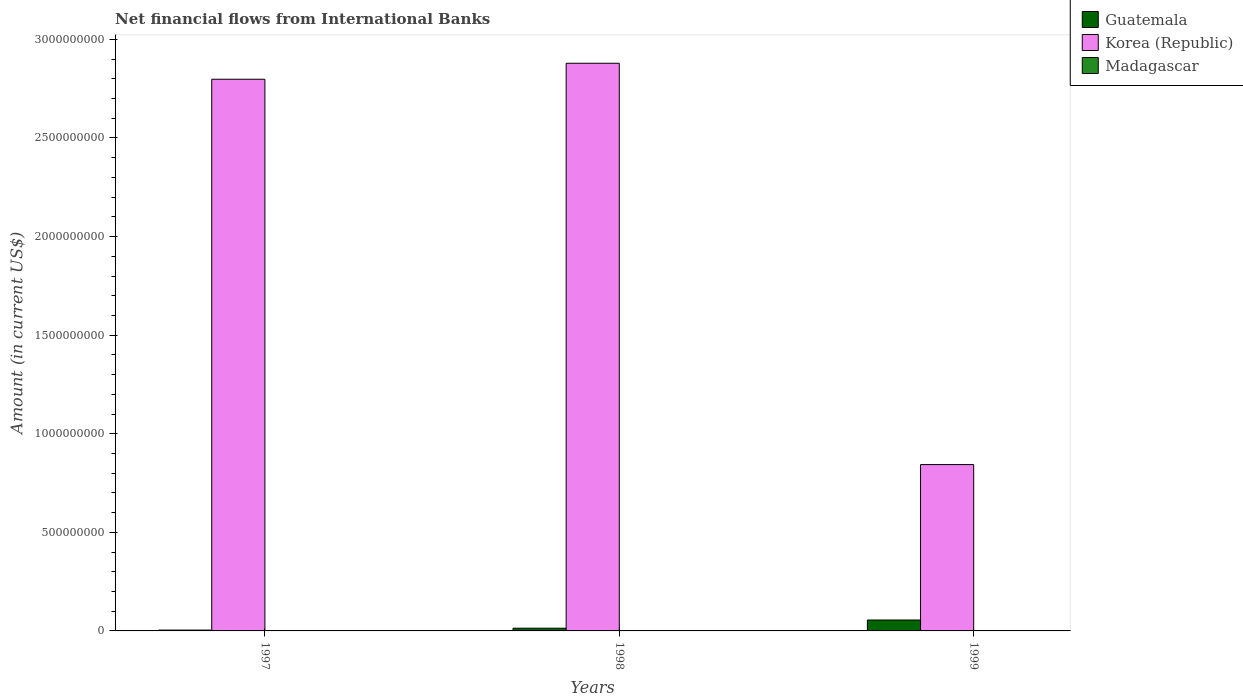How many different coloured bars are there?
Your response must be concise. 2. Are the number of bars per tick equal to the number of legend labels?
Keep it short and to the point. No. Are the number of bars on each tick of the X-axis equal?
Provide a succinct answer. Yes. How many bars are there on the 2nd tick from the left?
Keep it short and to the point. 2. How many bars are there on the 1st tick from the right?
Your response must be concise. 2. In how many cases, is the number of bars for a given year not equal to the number of legend labels?
Your answer should be very brief. 3. What is the net financial aid flows in Korea (Republic) in 1998?
Your answer should be very brief. 2.88e+09. Across all years, what is the maximum net financial aid flows in Guatemala?
Keep it short and to the point. 5.53e+07. Across all years, what is the minimum net financial aid flows in Korea (Republic)?
Offer a terse response. 8.44e+08. In which year was the net financial aid flows in Korea (Republic) maximum?
Ensure brevity in your answer.  1998. What is the total net financial aid flows in Korea (Republic) in the graph?
Ensure brevity in your answer.  6.52e+09. What is the difference between the net financial aid flows in Korea (Republic) in 1998 and that in 1999?
Offer a terse response. 2.04e+09. What is the difference between the net financial aid flows in Korea (Republic) in 1997 and the net financial aid flows in Madagascar in 1999?
Give a very brief answer. 2.80e+09. What is the average net financial aid flows in Korea (Republic) per year?
Provide a short and direct response. 2.17e+09. What is the ratio of the net financial aid flows in Guatemala in 1997 to that in 1999?
Give a very brief answer. 0.08. Is the net financial aid flows in Korea (Republic) in 1998 less than that in 1999?
Your answer should be compact. No. What is the difference between the highest and the second highest net financial aid flows in Korea (Republic)?
Make the answer very short. 8.11e+07. What is the difference between the highest and the lowest net financial aid flows in Guatemala?
Ensure brevity in your answer.  5.11e+07. Is the sum of the net financial aid flows in Guatemala in 1997 and 1999 greater than the maximum net financial aid flows in Madagascar across all years?
Your answer should be very brief. Yes. Is it the case that in every year, the sum of the net financial aid flows in Madagascar and net financial aid flows in Guatemala is greater than the net financial aid flows in Korea (Republic)?
Make the answer very short. No. How many bars are there?
Provide a succinct answer. 6. Are all the bars in the graph horizontal?
Your response must be concise. No. How many years are there in the graph?
Make the answer very short. 3. Are the values on the major ticks of Y-axis written in scientific E-notation?
Make the answer very short. No. Does the graph contain any zero values?
Make the answer very short. Yes. Does the graph contain grids?
Your answer should be compact. No. How many legend labels are there?
Offer a terse response. 3. How are the legend labels stacked?
Keep it short and to the point. Vertical. What is the title of the graph?
Keep it short and to the point. Net financial flows from International Banks. Does "Niger" appear as one of the legend labels in the graph?
Offer a terse response. No. What is the Amount (in current US$) in Guatemala in 1997?
Provide a short and direct response. 4.26e+06. What is the Amount (in current US$) of Korea (Republic) in 1997?
Provide a succinct answer. 2.80e+09. What is the Amount (in current US$) in Guatemala in 1998?
Offer a very short reply. 1.38e+07. What is the Amount (in current US$) of Korea (Republic) in 1998?
Offer a terse response. 2.88e+09. What is the Amount (in current US$) in Madagascar in 1998?
Provide a succinct answer. 0. What is the Amount (in current US$) of Guatemala in 1999?
Provide a succinct answer. 5.53e+07. What is the Amount (in current US$) in Korea (Republic) in 1999?
Offer a terse response. 8.44e+08. Across all years, what is the maximum Amount (in current US$) of Guatemala?
Offer a very short reply. 5.53e+07. Across all years, what is the maximum Amount (in current US$) in Korea (Republic)?
Your answer should be compact. 2.88e+09. Across all years, what is the minimum Amount (in current US$) of Guatemala?
Offer a terse response. 4.26e+06. Across all years, what is the minimum Amount (in current US$) of Korea (Republic)?
Offer a very short reply. 8.44e+08. What is the total Amount (in current US$) in Guatemala in the graph?
Make the answer very short. 7.34e+07. What is the total Amount (in current US$) of Korea (Republic) in the graph?
Offer a terse response. 6.52e+09. What is the difference between the Amount (in current US$) in Guatemala in 1997 and that in 1998?
Ensure brevity in your answer.  -9.52e+06. What is the difference between the Amount (in current US$) of Korea (Republic) in 1997 and that in 1998?
Make the answer very short. -8.11e+07. What is the difference between the Amount (in current US$) in Guatemala in 1997 and that in 1999?
Make the answer very short. -5.11e+07. What is the difference between the Amount (in current US$) of Korea (Republic) in 1997 and that in 1999?
Your answer should be very brief. 1.95e+09. What is the difference between the Amount (in current US$) of Guatemala in 1998 and that in 1999?
Keep it short and to the point. -4.15e+07. What is the difference between the Amount (in current US$) of Korea (Republic) in 1998 and that in 1999?
Provide a succinct answer. 2.04e+09. What is the difference between the Amount (in current US$) in Guatemala in 1997 and the Amount (in current US$) in Korea (Republic) in 1998?
Your response must be concise. -2.87e+09. What is the difference between the Amount (in current US$) in Guatemala in 1997 and the Amount (in current US$) in Korea (Republic) in 1999?
Give a very brief answer. -8.39e+08. What is the difference between the Amount (in current US$) of Guatemala in 1998 and the Amount (in current US$) of Korea (Republic) in 1999?
Offer a very short reply. -8.30e+08. What is the average Amount (in current US$) in Guatemala per year?
Offer a very short reply. 2.45e+07. What is the average Amount (in current US$) in Korea (Republic) per year?
Provide a short and direct response. 2.17e+09. What is the average Amount (in current US$) of Madagascar per year?
Provide a short and direct response. 0. In the year 1997, what is the difference between the Amount (in current US$) of Guatemala and Amount (in current US$) of Korea (Republic)?
Make the answer very short. -2.79e+09. In the year 1998, what is the difference between the Amount (in current US$) in Guatemala and Amount (in current US$) in Korea (Republic)?
Your response must be concise. -2.87e+09. In the year 1999, what is the difference between the Amount (in current US$) of Guatemala and Amount (in current US$) of Korea (Republic)?
Keep it short and to the point. -7.88e+08. What is the ratio of the Amount (in current US$) in Guatemala in 1997 to that in 1998?
Offer a terse response. 0.31. What is the ratio of the Amount (in current US$) of Korea (Republic) in 1997 to that in 1998?
Your response must be concise. 0.97. What is the ratio of the Amount (in current US$) of Guatemala in 1997 to that in 1999?
Offer a very short reply. 0.08. What is the ratio of the Amount (in current US$) in Korea (Republic) in 1997 to that in 1999?
Give a very brief answer. 3.32. What is the ratio of the Amount (in current US$) in Guatemala in 1998 to that in 1999?
Give a very brief answer. 0.25. What is the ratio of the Amount (in current US$) in Korea (Republic) in 1998 to that in 1999?
Ensure brevity in your answer.  3.41. What is the difference between the highest and the second highest Amount (in current US$) of Guatemala?
Give a very brief answer. 4.15e+07. What is the difference between the highest and the second highest Amount (in current US$) of Korea (Republic)?
Offer a terse response. 8.11e+07. What is the difference between the highest and the lowest Amount (in current US$) in Guatemala?
Ensure brevity in your answer.  5.11e+07. What is the difference between the highest and the lowest Amount (in current US$) of Korea (Republic)?
Keep it short and to the point. 2.04e+09. 